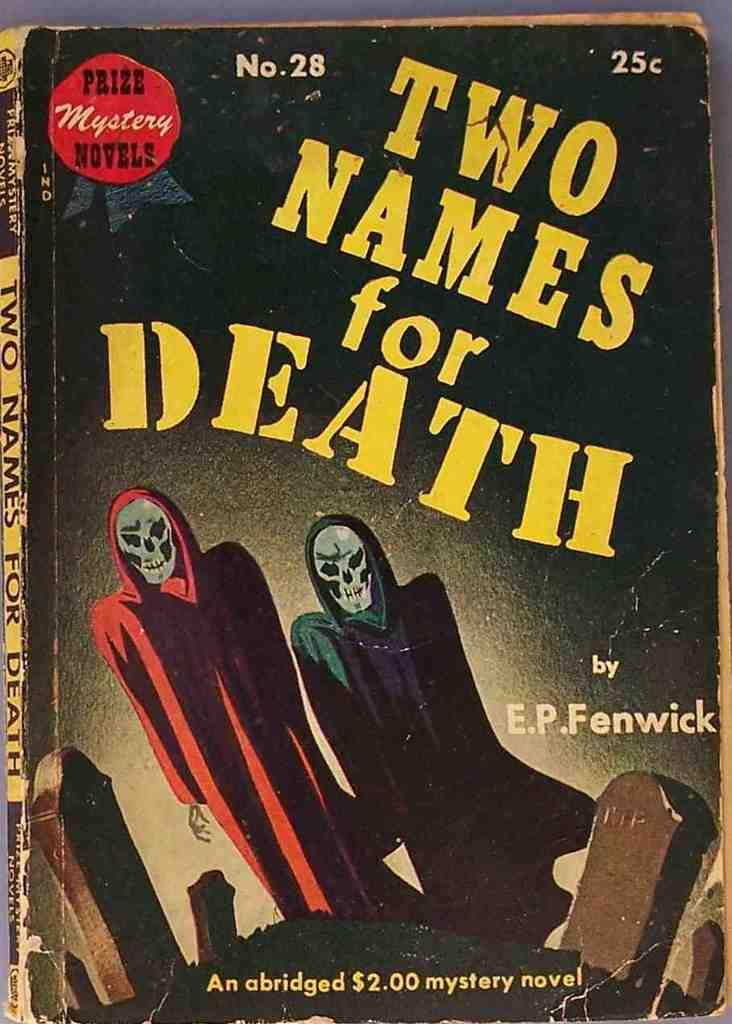<image>
Provide a brief description of the given image. A book with two skeletons on the cover called Two Names for Death. 